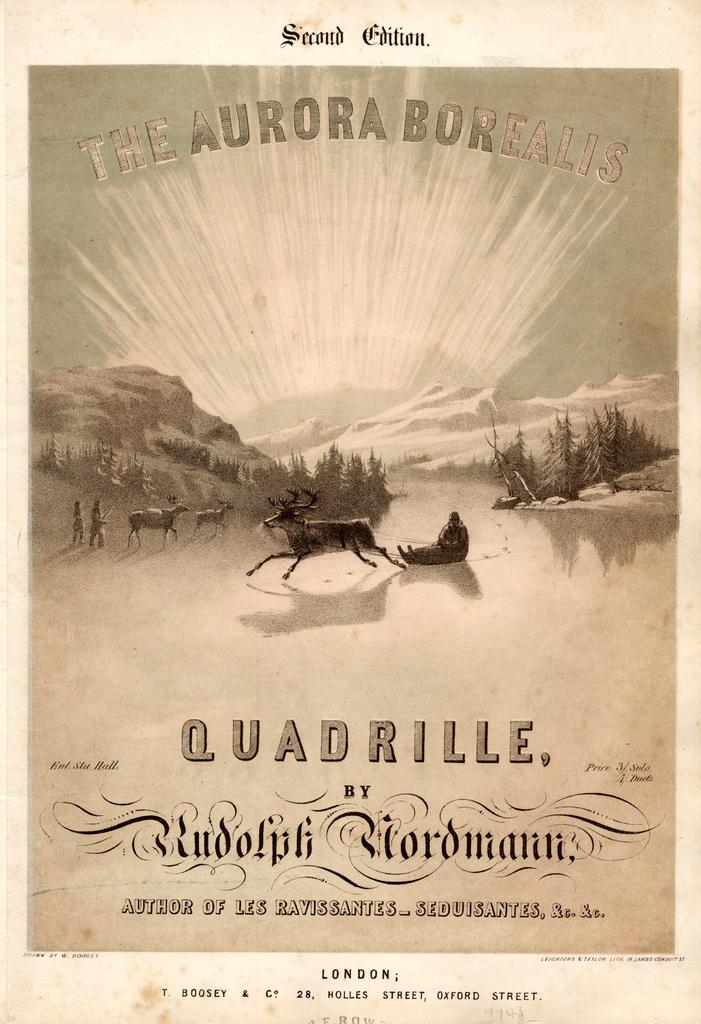<image>
Present a compact description of the photo's key features. A Quadrille program with reindeer on the front page. 